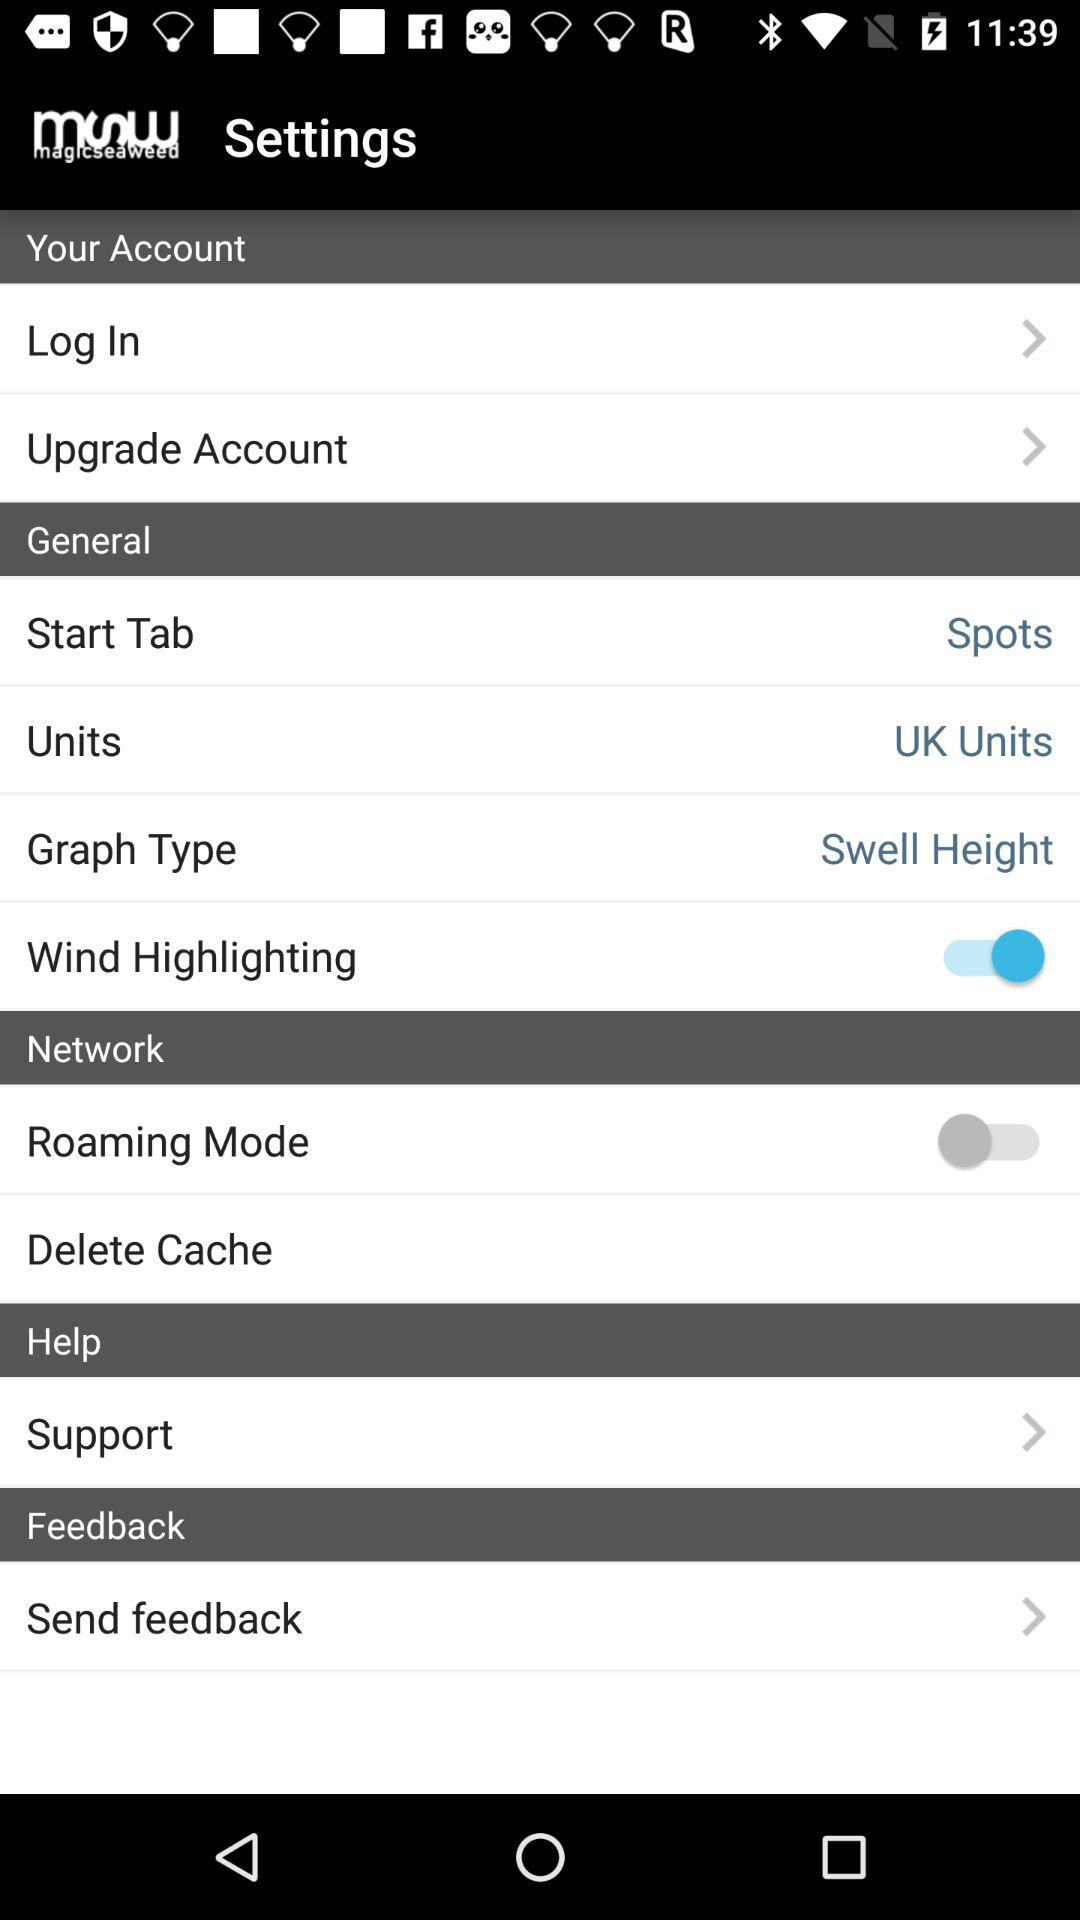Define the application name? The application name is "magicseaweed". 